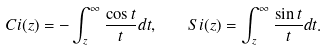<formula> <loc_0><loc_0><loc_500><loc_500>C i ( z ) = - \int _ { z } ^ { \infty } \frac { \cos { t } } { t } d t , \quad S i ( z ) = \int _ { z } ^ { \infty } \frac { \sin { t } } { t } d t .</formula> 